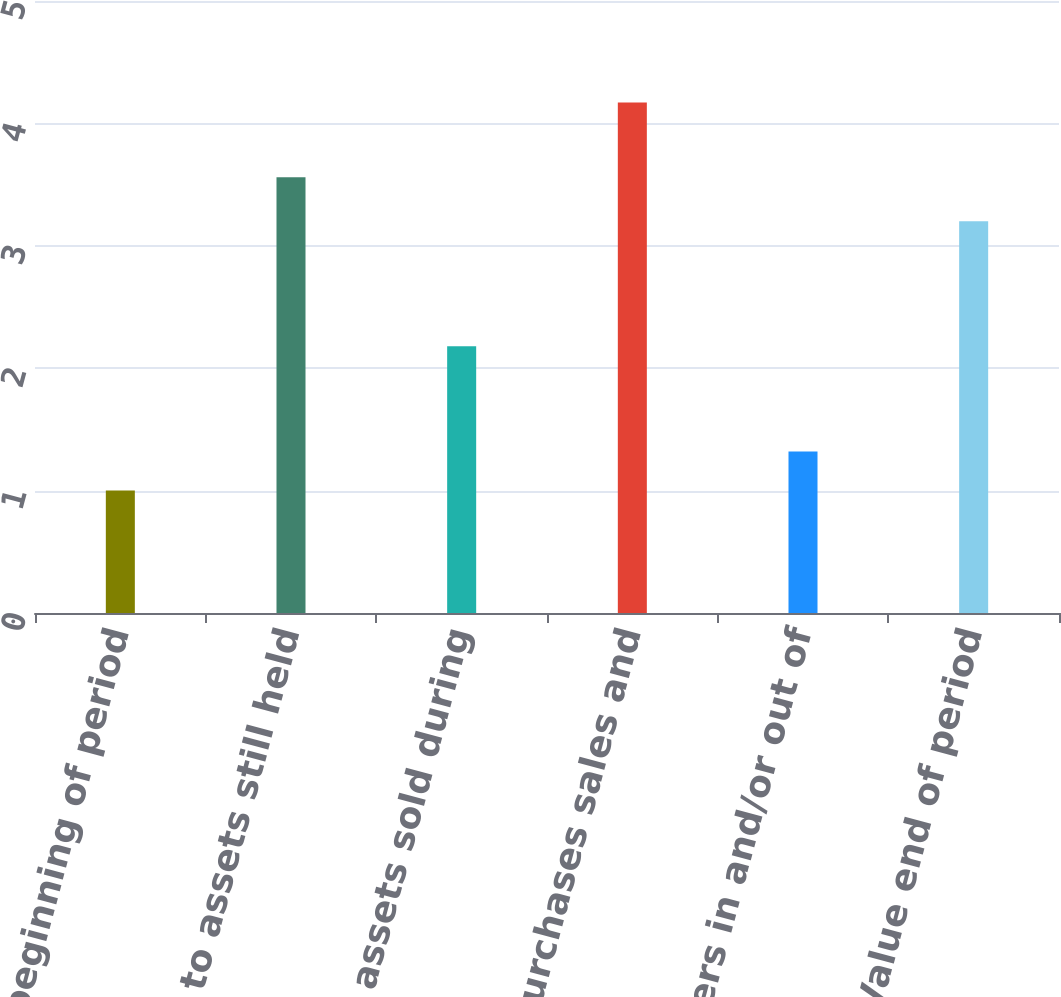<chart> <loc_0><loc_0><loc_500><loc_500><bar_chart><fcel>Fair Value beginning of period<fcel>Relating to assets still held<fcel>Relating to assets sold during<fcel>Purchases sales and<fcel>Transfers in and/or out of<fcel>Fair Value end of period<nl><fcel>1<fcel>3.56<fcel>2.18<fcel>4.17<fcel>1.32<fcel>3.2<nl></chart> 